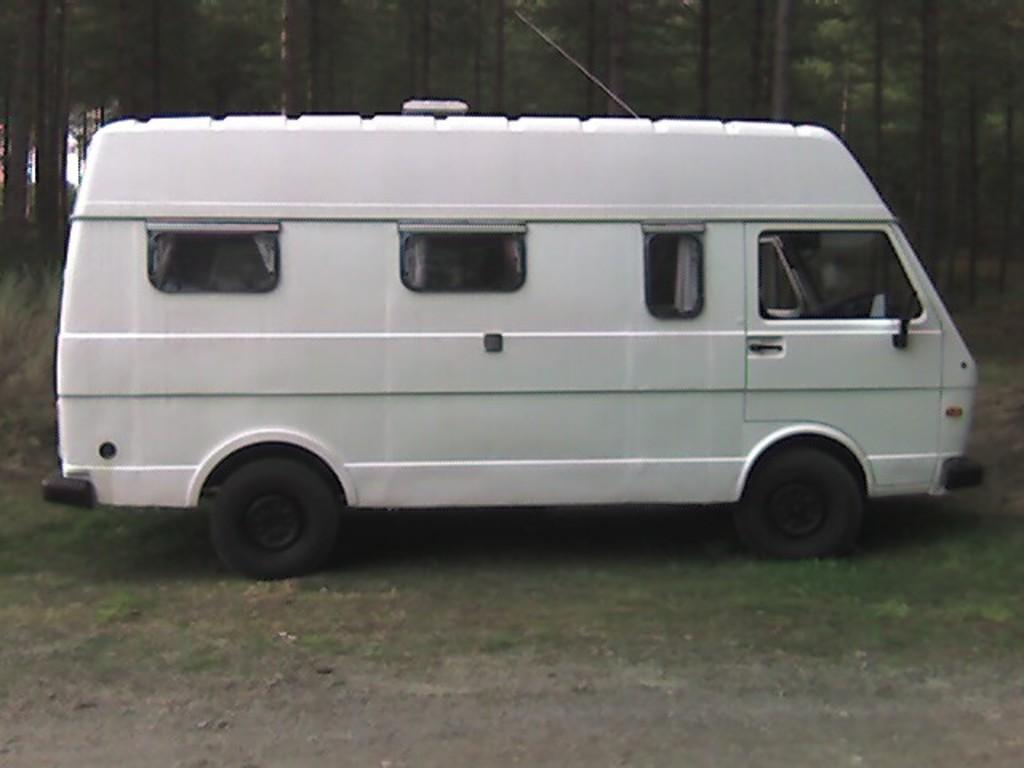What is the main subject of the image? There is a vehicle in the image. Where is the vehicle located? The vehicle is on the ground. What type of natural environment is visible in the image? There is grass and trees visible in the image. What color is the crayon used to draw the trees in the image? There is no crayon present in the image, and the trees are not drawn; they are real trees in the natural environment. 